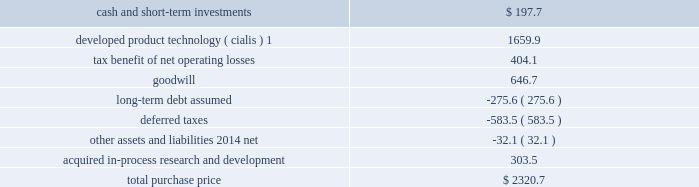Icos corporation on january 29 , 2007 , we acquired all of the outstanding common stock of icos corporation ( icos ) , our partner in the lilly icos llc joint venture for the manufacture and sale of cialis for the treatment of erectile dysfunction .
The acquisition brought the full value of cialis to us and enabled us to realize operational effi ciencies in the further development , marketing , and selling of this product .
The aggregate cash purchase price of approximately $ 2.3 bil- lion was fi nanced through borrowings .
The acquisition has been accounted for as a business combination under the purchase method of accounting , resulting in goodwill of $ 646.7 million .
No portion of this goodwill was deductible for tax purposes .
We determined the following estimated fair values for the assets acquired and liabilities assumed as of the date of acquisition .
Estimated fair value at january 29 , 2007 .
1this intangible asset will be amortized over the remaining expected patent lives of cialis in each country ; patent expiry dates range from 2015 to 2017 .
New indications for and formulations of the cialis compound in clinical testing at the time of the acquisition represented approximately 48 percent of the estimated fair value of the acquired ipr&d .
The remaining value of acquired ipr&d represented several other products in development , with no one asset comprising a signifi cant por- tion of this value .
The discount rate we used in valuing the acquired ipr&d projects was 20 percent , and the charge for acquired ipr&d of $ 303.5 million recorded in the fi rst quarter of 2007 was not deductible for tax purposes .
Other acquisitions during the second quarter of 2007 , we acquired all of the outstanding stock of both hypnion , inc .
( hypnion ) , a privately held neuroscience drug discovery company focused on sleep disorders , and ivy animal health , inc .
( ivy ) , a privately held applied research and pharmaceutical product development company focused on the animal health industry , for $ 445.0 million in cash .
The acquisition of hypnion provided us with a broader and more substantive presence in the area of sleep disorder research and ownership of hy10275 , a novel phase ii compound with a dual mechanism of action aimed at promoting better sleep onset and sleep maintenance .
This was hypnion 2019s only signifi cant asset .
For this acquisi- tion , we recorded an acquired ipr&d charge of $ 291.1 million , which was not deductible for tax purposes .
Because hypnion was a development-stage company , the transaction was accounted for as an acquisition of assets rather than as a business combination and , therefore , goodwill was not recorded .
The acquisition of ivy provides us with products that complement those of our animal health business .
This acquisition has been accounted for as a business combination under the purchase method of accounting .
We allocated $ 88.7 million of the purchase price to other identifi able intangible assets , primarily related to marketed products , $ 37.0 million to acquired ipr&d , and $ 25.0 million to goodwill .
The other identifi able intangible assets are being amortized over their estimated remaining useful lives of 10 to 20 years .
The $ 37.0 million allocated to acquired ipr&d was charged to expense in the second quarter of 2007 .
Goodwill resulting from this acquisition was fully allocated to the animal health business segment .
The amount allocated to each of the intangible assets acquired , including goodwill of $ 25.0 million and the acquired ipr&d of $ 37.0 million , was deductible for tax purposes .
Product acquisitions in june 2008 , we entered into a licensing and development agreement with transpharma medical ltd .
( trans- pharma ) to acquire rights to its product and related drug delivery system for the treatment of osteoporosis .
The product , which is administered transdermally using transpharma 2019s proprietary technology , was in phase ii clinical testing , and had no alternative future use .
Under the arrangement , we also gained non-exclusive access to trans- pharma 2019s viaderm drug delivery system for the product .
As with many development-phase products , launch of the .
What percentage of the total purchase price was comprised of developed product technology ( cialis ) ? 
Computations: (1659.9 / 2320.7)
Answer: 0.71526. 